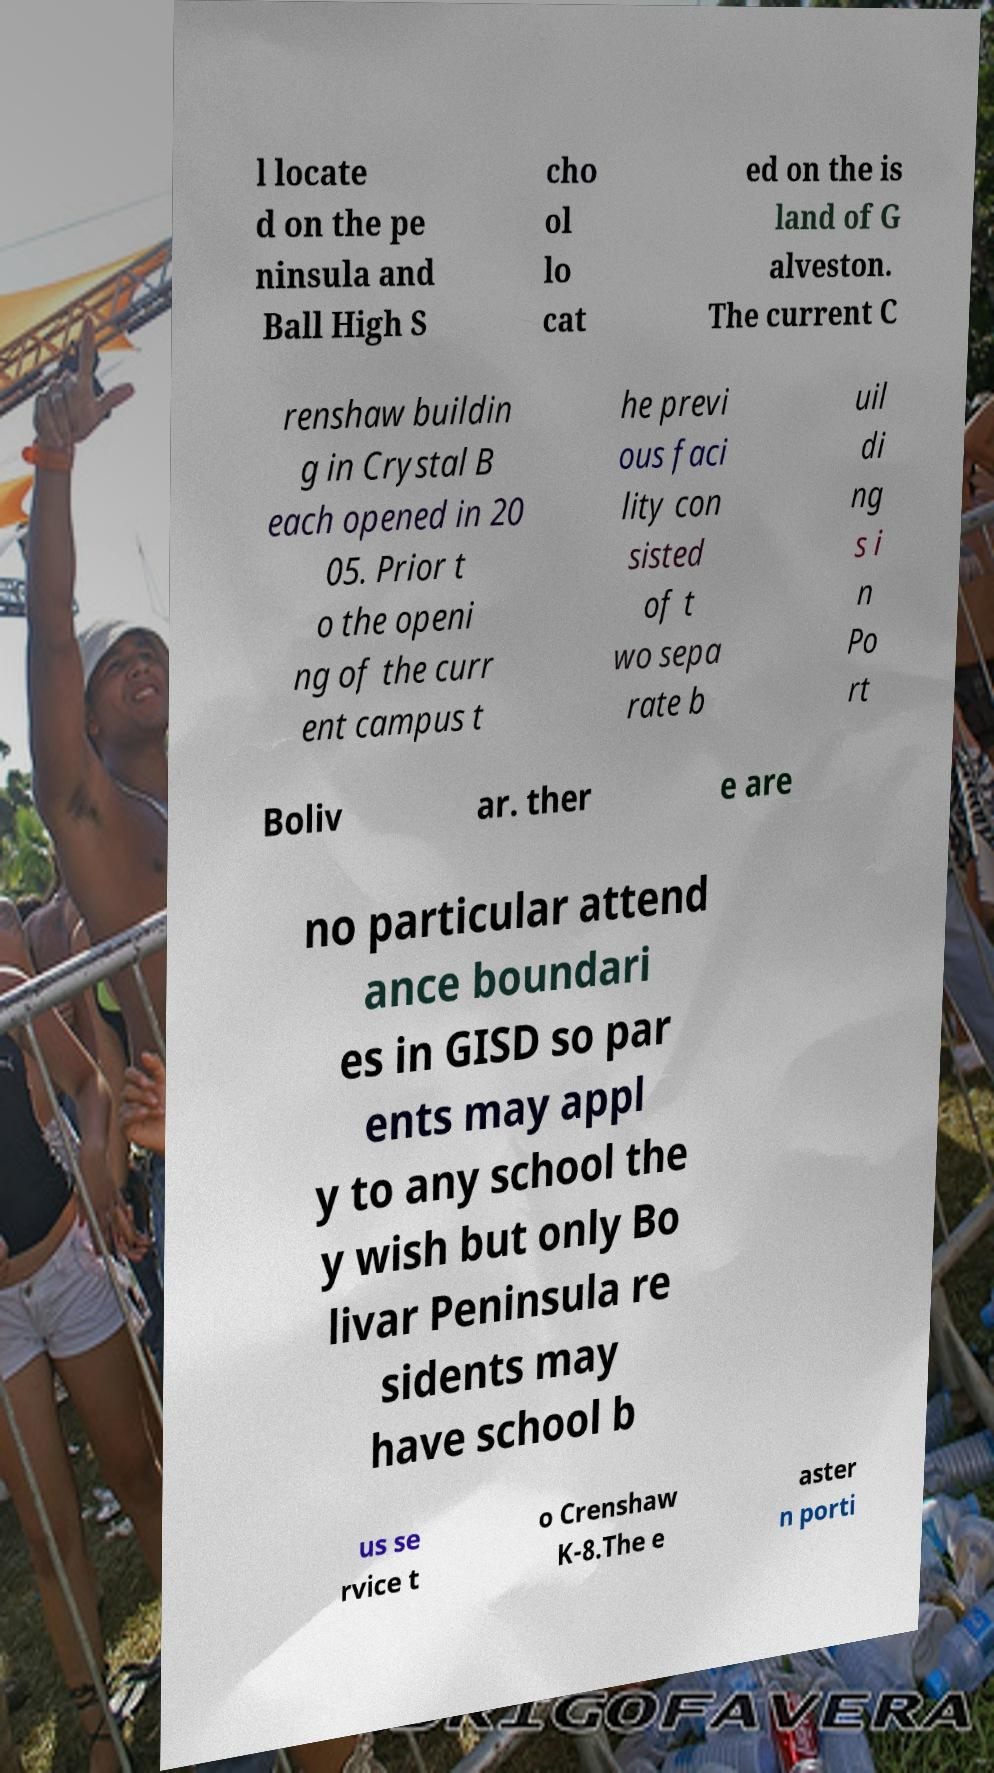Could you extract and type out the text from this image? l locate d on the pe ninsula and Ball High S cho ol lo cat ed on the is land of G alveston. The current C renshaw buildin g in Crystal B each opened in 20 05. Prior t o the openi ng of the curr ent campus t he previ ous faci lity con sisted of t wo sepa rate b uil di ng s i n Po rt Boliv ar. ther e are no particular attend ance boundari es in GISD so par ents may appl y to any school the y wish but only Bo livar Peninsula re sidents may have school b us se rvice t o Crenshaw K-8.The e aster n porti 